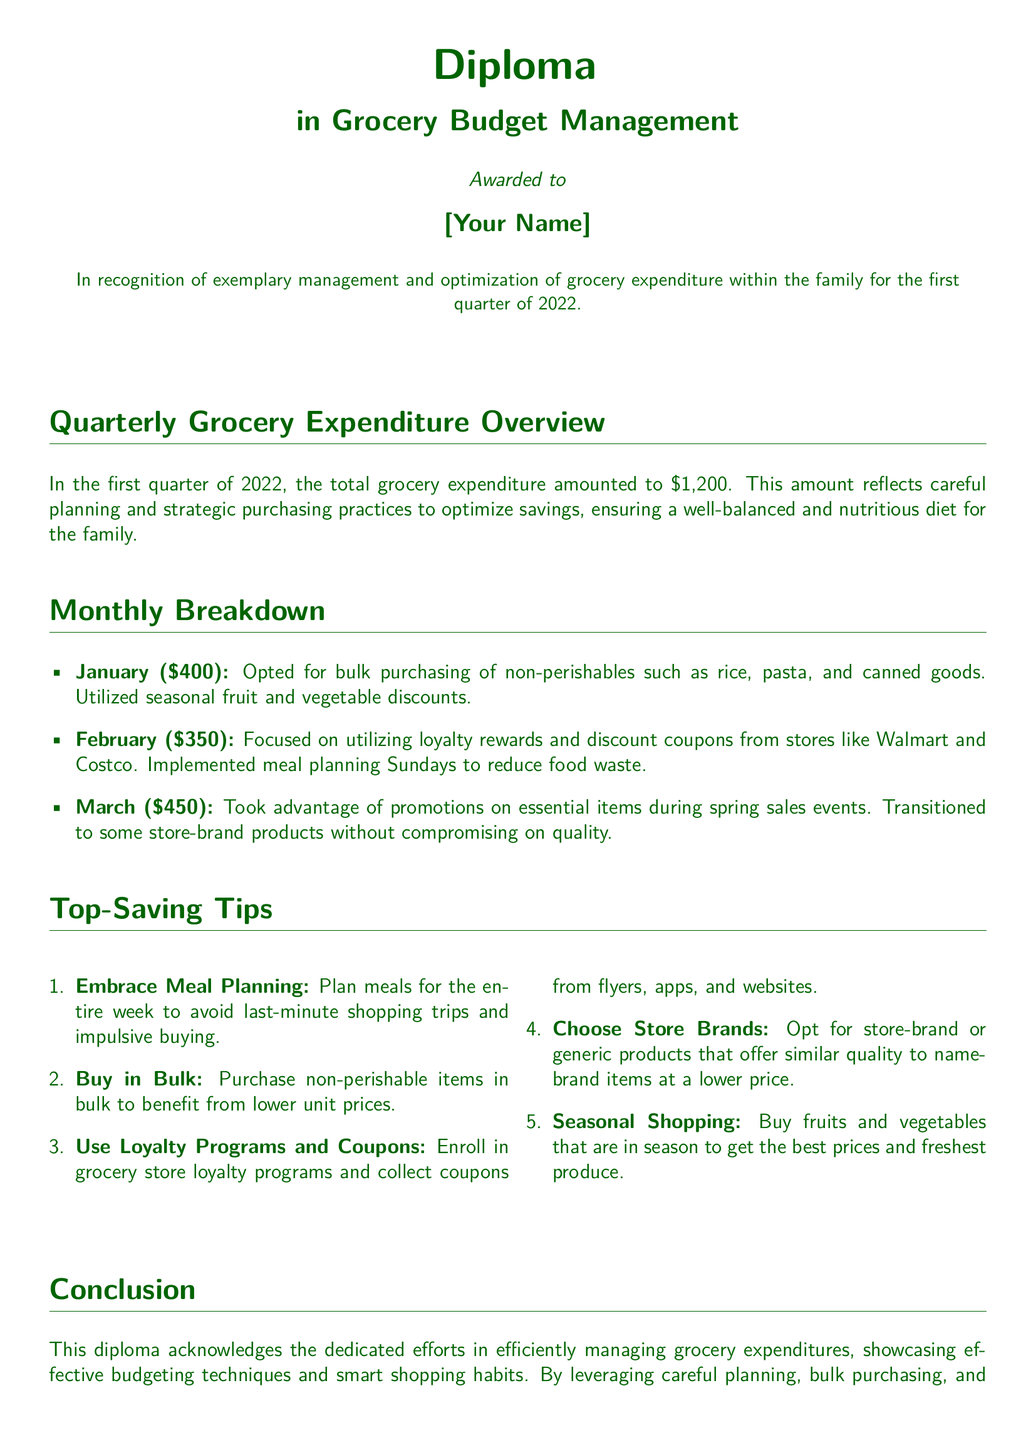What is the total grocery expenditure for the first quarter of 2022? The total grocery expenditure is mentioned in the overview as $1,200.
Answer: $1,200 How much was spent on groceries in February? The document states the expenditure for February is detailed in the monthly breakdown, which is $350.
Answer: $350 What were the grocery savings tips about? The tips are on ways to save money on grocery expenditures, as outlined in the "Top-Saving Tips" section.
Answer: Top-Saving Tips How many dollars were spent on groceries in March? The amount spent in March is clearly stated in the monthly breakdown as $450.
Answer: $450 What is the main theme of the diploma? The diploma recognizes the management and optimization of grocery expenditure in the family, as noted in the introduction.
Answer: Grocery Budget Management What strategy was used to optimize grocery expenditure in January? The document specifies “bulk purchasing of non-perishables” as a key strategy in January.
Answer: Bulk purchasing Which store loyalty program is mentioned in the document? The document references loyalty rewards and discount coupons from specific stores, including Walmart and Costco.
Answer: Walmart and Costco When was this diploma awarded? The date of the award is mentioned at the end of the document, which is April 2022.
Answer: April 2022 What percentage (rounded) of the total was spent in January? To find this, January's expenditure ($400) is divided by the total ($1,200) and multiplied by 100, showing it was 33.33%, roughly 33%.
Answer: 33% 